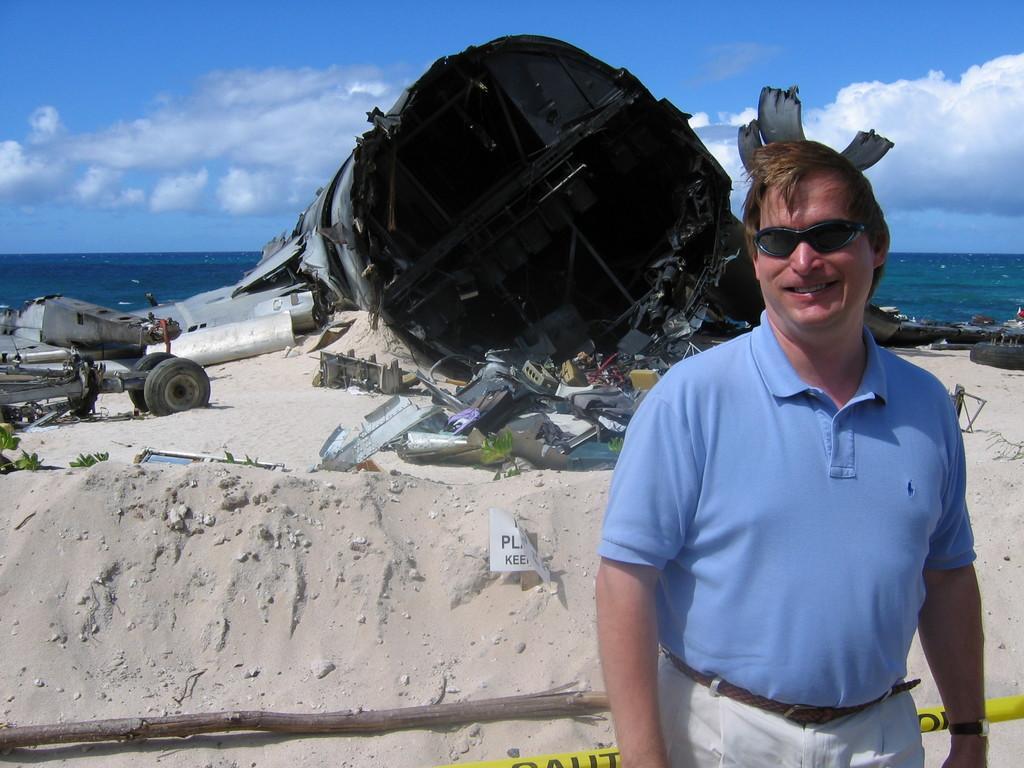In one or two sentences, can you explain what this image depicts? There is a man standing and smiling and wore glasses,behind this man we can see vehicle,tire,wooden stick and some objects on the sand. In the background we can see water and sky with clouds. 